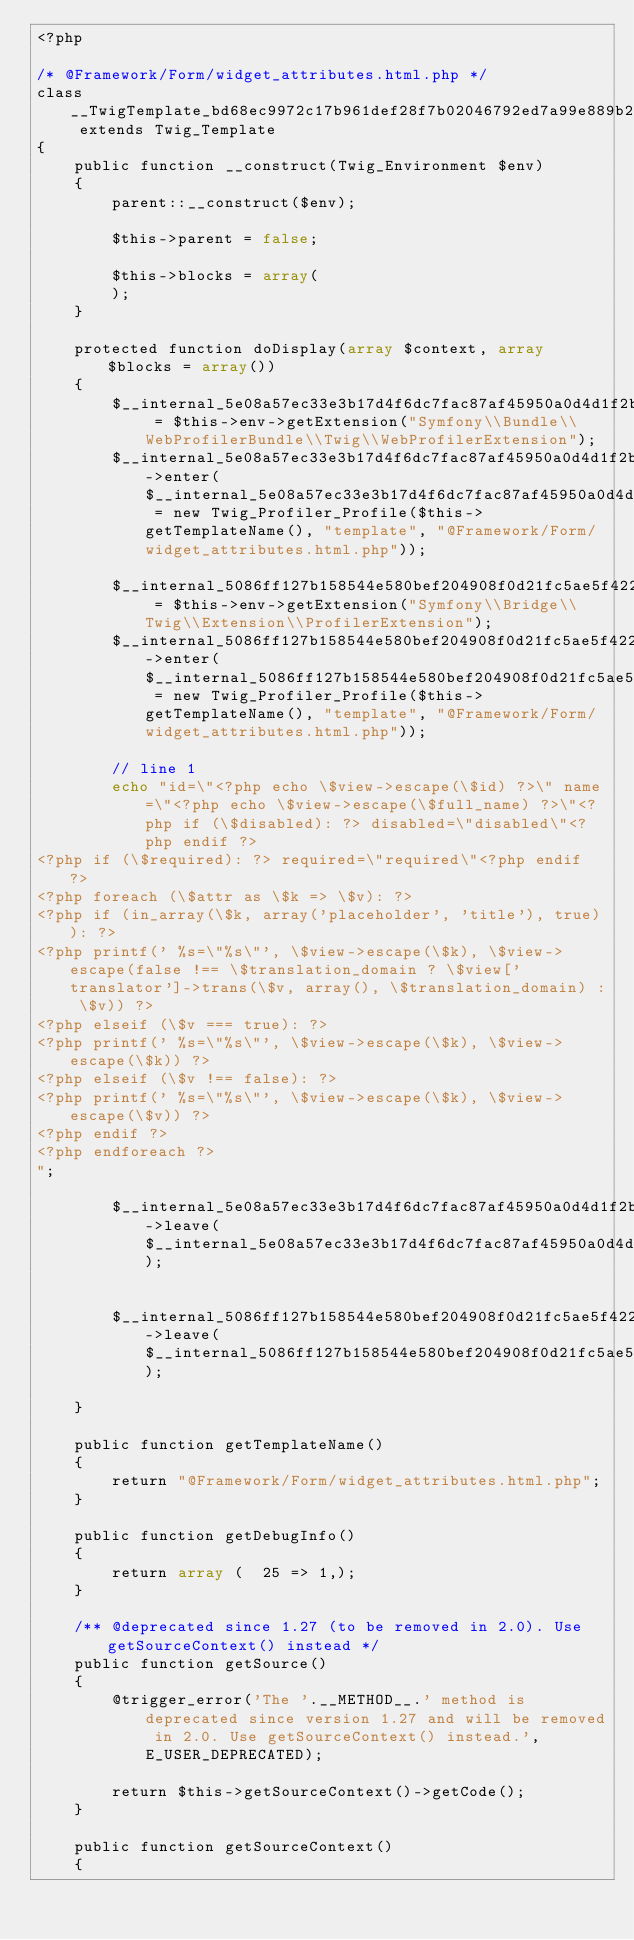<code> <loc_0><loc_0><loc_500><loc_500><_PHP_><?php

/* @Framework/Form/widget_attributes.html.php */
class __TwigTemplate_bd68ec9972c17b961def28f7b02046792ed7a99e889b27a31e54854fbb582d60 extends Twig_Template
{
    public function __construct(Twig_Environment $env)
    {
        parent::__construct($env);

        $this->parent = false;

        $this->blocks = array(
        );
    }

    protected function doDisplay(array $context, array $blocks = array())
    {
        $__internal_5e08a57ec33e3b17d4f6dc7fac87af45950a0d4d1f2b16f2125a228d6b45ed53 = $this->env->getExtension("Symfony\\Bundle\\WebProfilerBundle\\Twig\\WebProfilerExtension");
        $__internal_5e08a57ec33e3b17d4f6dc7fac87af45950a0d4d1f2b16f2125a228d6b45ed53->enter($__internal_5e08a57ec33e3b17d4f6dc7fac87af45950a0d4d1f2b16f2125a228d6b45ed53_prof = new Twig_Profiler_Profile($this->getTemplateName(), "template", "@Framework/Form/widget_attributes.html.php"));

        $__internal_5086ff127b158544e580bef204908f0d21fc5ae5f42275c445ebe868f869a5fd = $this->env->getExtension("Symfony\\Bridge\\Twig\\Extension\\ProfilerExtension");
        $__internal_5086ff127b158544e580bef204908f0d21fc5ae5f42275c445ebe868f869a5fd->enter($__internal_5086ff127b158544e580bef204908f0d21fc5ae5f42275c445ebe868f869a5fd_prof = new Twig_Profiler_Profile($this->getTemplateName(), "template", "@Framework/Form/widget_attributes.html.php"));

        // line 1
        echo "id=\"<?php echo \$view->escape(\$id) ?>\" name=\"<?php echo \$view->escape(\$full_name) ?>\"<?php if (\$disabled): ?> disabled=\"disabled\"<?php endif ?>
<?php if (\$required): ?> required=\"required\"<?php endif ?>
<?php foreach (\$attr as \$k => \$v): ?>
<?php if (in_array(\$k, array('placeholder', 'title'), true)): ?>
<?php printf(' %s=\"%s\"', \$view->escape(\$k), \$view->escape(false !== \$translation_domain ? \$view['translator']->trans(\$v, array(), \$translation_domain) : \$v)) ?>
<?php elseif (\$v === true): ?>
<?php printf(' %s=\"%s\"', \$view->escape(\$k), \$view->escape(\$k)) ?>
<?php elseif (\$v !== false): ?>
<?php printf(' %s=\"%s\"', \$view->escape(\$k), \$view->escape(\$v)) ?>
<?php endif ?>
<?php endforeach ?>
";
        
        $__internal_5e08a57ec33e3b17d4f6dc7fac87af45950a0d4d1f2b16f2125a228d6b45ed53->leave($__internal_5e08a57ec33e3b17d4f6dc7fac87af45950a0d4d1f2b16f2125a228d6b45ed53_prof);

        
        $__internal_5086ff127b158544e580bef204908f0d21fc5ae5f42275c445ebe868f869a5fd->leave($__internal_5086ff127b158544e580bef204908f0d21fc5ae5f42275c445ebe868f869a5fd_prof);

    }

    public function getTemplateName()
    {
        return "@Framework/Form/widget_attributes.html.php";
    }

    public function getDebugInfo()
    {
        return array (  25 => 1,);
    }

    /** @deprecated since 1.27 (to be removed in 2.0). Use getSourceContext() instead */
    public function getSource()
    {
        @trigger_error('The '.__METHOD__.' method is deprecated since version 1.27 and will be removed in 2.0. Use getSourceContext() instead.', E_USER_DEPRECATED);

        return $this->getSourceContext()->getCode();
    }

    public function getSourceContext()
    {</code> 